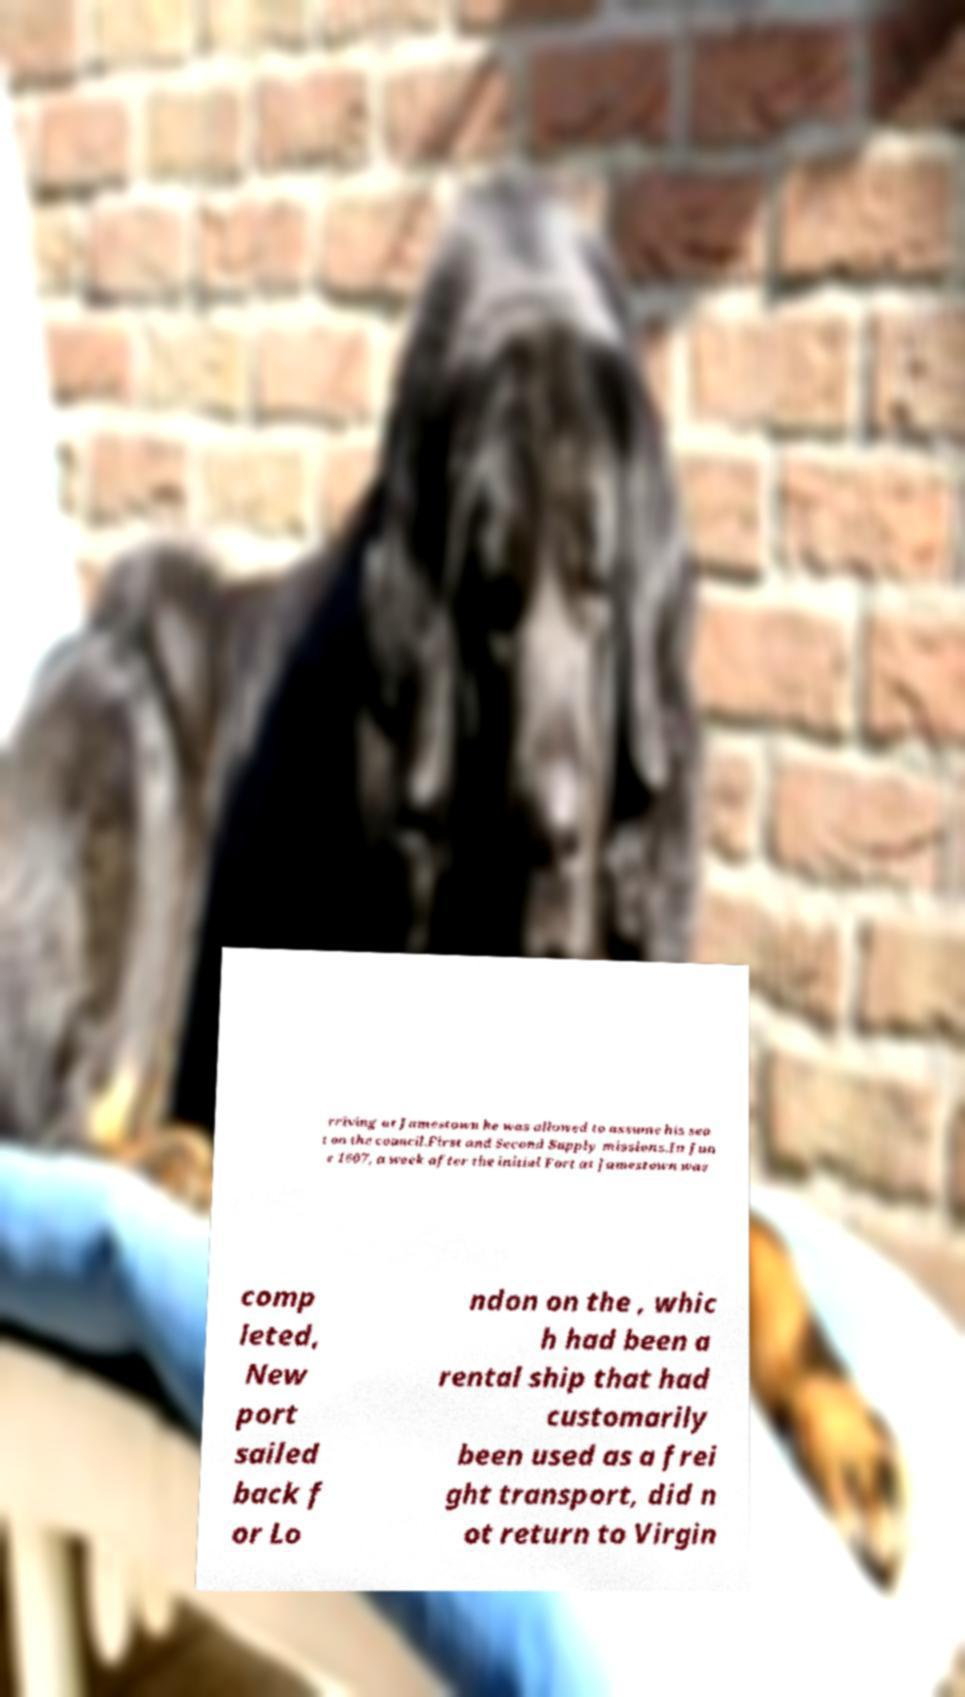For documentation purposes, I need the text within this image transcribed. Could you provide that? rriving at Jamestown he was allowed to assume his sea t on the council.First and Second Supply missions.In Jun e 1607, a week after the initial Fort at Jamestown was comp leted, New port sailed back f or Lo ndon on the , whic h had been a rental ship that had customarily been used as a frei ght transport, did n ot return to Virgin 